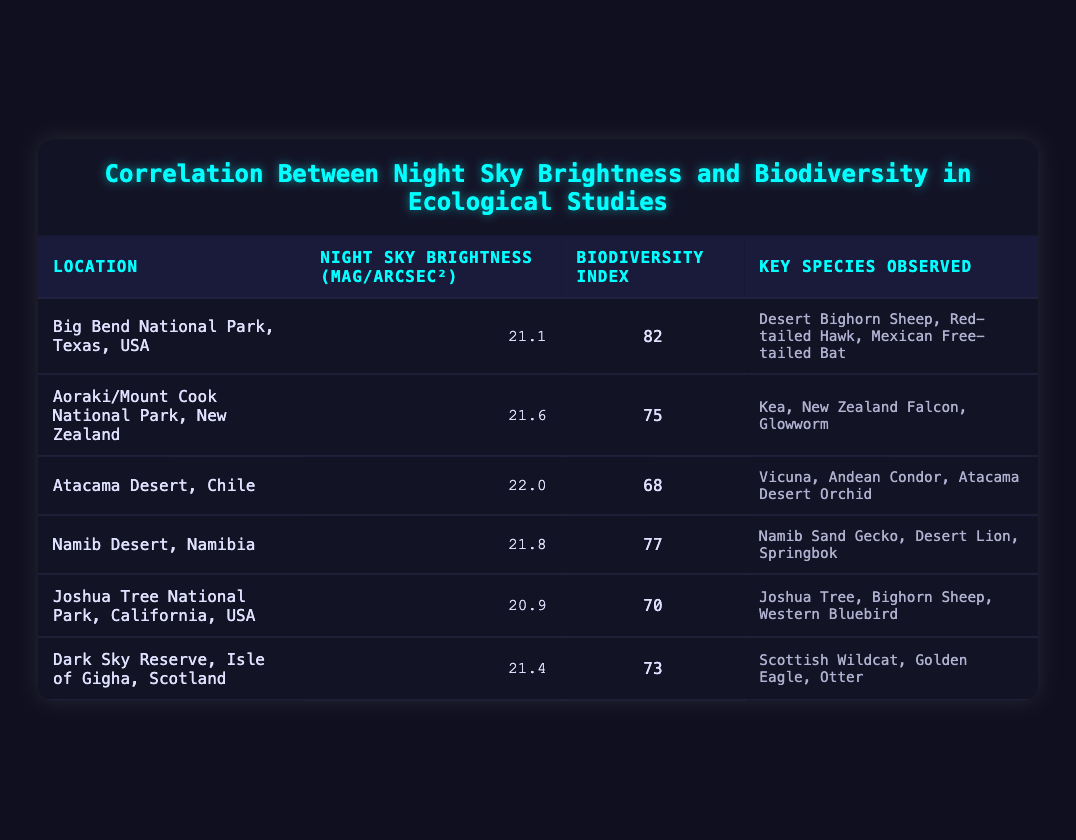What is the Night Sky Brightness of Big Bend National Park, Texas, USA? The table lists Big Bend National Park, Texas, USA, and the corresponding Night Sky Brightness value is shown in that row, which is 21.1 mag/arcsec².
Answer: 21.1 mag/arcsec² Which location has the highest Biodiversity Index? By comparing the Biodiversity Index values across all locations listed in the table, Big Bend National Park has the highest value of 82, making it the location with the highest Biodiversity Index.
Answer: Big Bend National Park, Texas, USA What is the average Night Sky Brightness across all locations? First, we will sum the Night Sky Brightness values: 21.1 + 21.6 + 22.0 + 21.8 + 20.9 + 21.4 = 128.8. Then, we divide by the number of locations (6) to get the average: 128.8 / 6 = 21.47 mag/arcsec².
Answer: 21.47 mag/arcsec² Is there a location with a Night Sky Brightness of 20.9 mag/arcsec²? Looking through the table, the Night Sky Brightness 20.9 mag/arcsec² is present in the row for Joshua Tree National Park, confirming the existence of this value.
Answer: Yes Which species is observed in both Big Bend National Park and Joshua Tree National Park? By reviewing the key species in both respective rows, "Bighorn Sheep" is listed as a key species in Big Bend National Park and also appears in Joshua Tree National Park, indicating it is observed in both locations.
Answer: Bighorn Sheep 